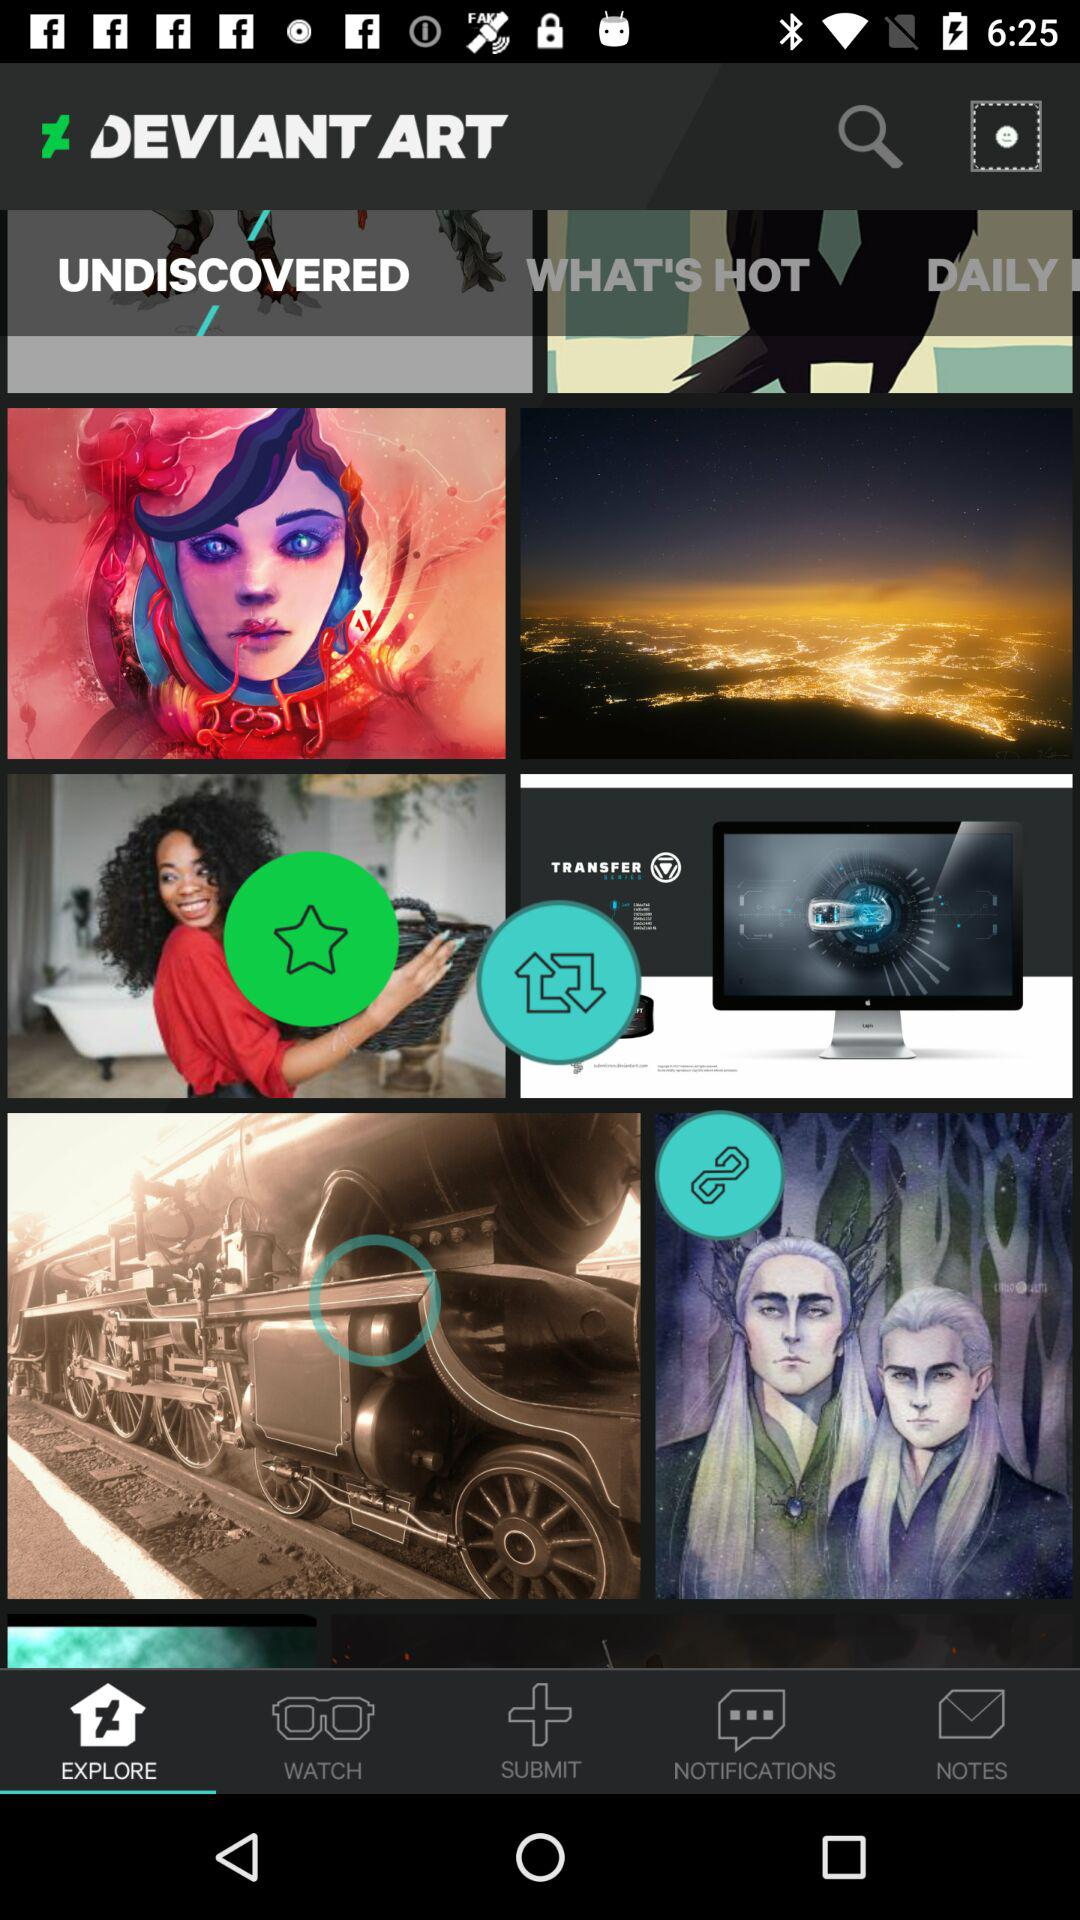What is the email address? The email address is appcrawler4@gmail.com. 